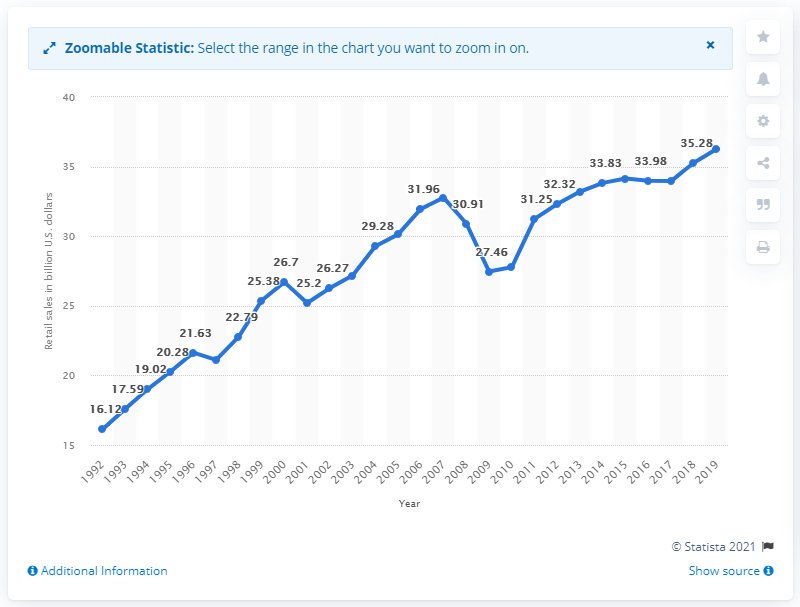Specify some key components in this picture. In the United States, the sales of jewelry, luggage, and leather goods stores in 2019 was $36.26 billion. 